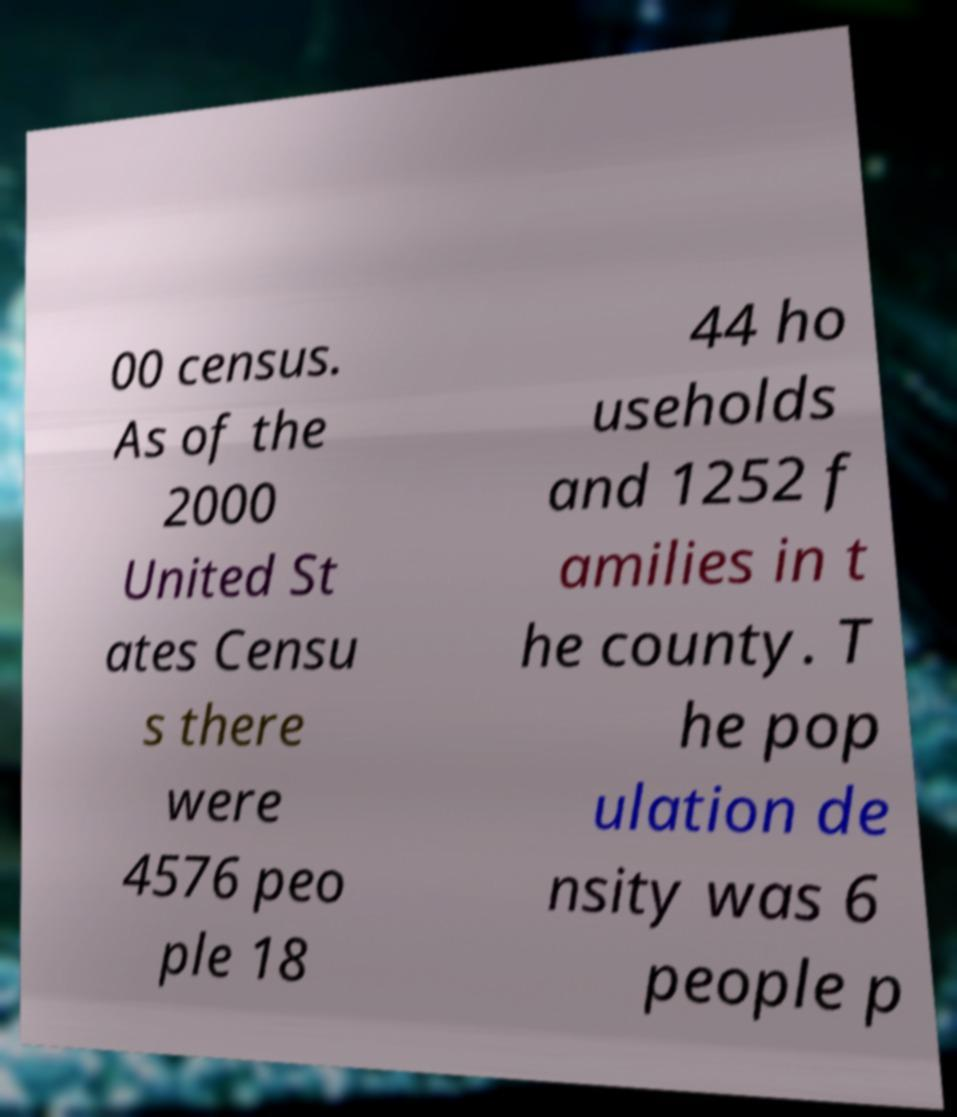Can you accurately transcribe the text from the provided image for me? 00 census. As of the 2000 United St ates Censu s there were 4576 peo ple 18 44 ho useholds and 1252 f amilies in t he county. T he pop ulation de nsity was 6 people p 